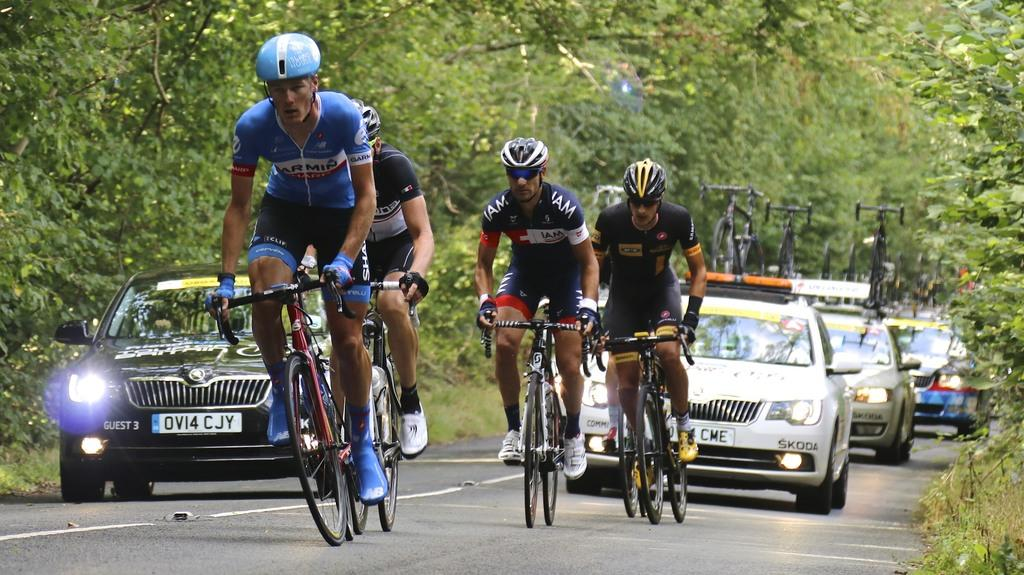What are the people in the image doing? The people in the image are cycling on the road. Are there any vehicles in the image? Yes, there are cars following the cycling group. What type of popcorn is being served to the cyclists in the image? There is no popcorn present in the image; the people are cycling on the road. Who is the representative of the cycling group in the image? The image does not indicate the presence of a representative for the cycling group. 